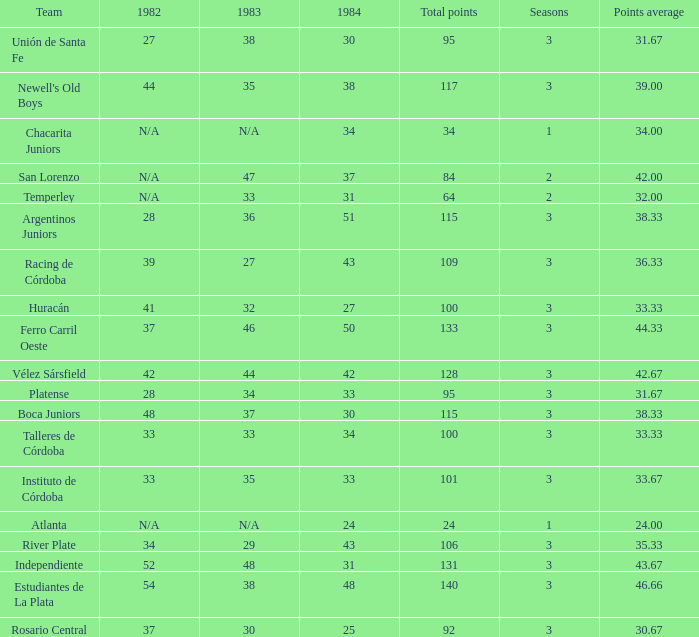Can you give me this table as a dict? {'header': ['Team', '1982', '1983', '1984', 'Total points', 'Seasons', 'Points average'], 'rows': [['Unión de Santa Fe', '27', '38', '30', '95', '3', '31.67'], ["Newell's Old Boys", '44', '35', '38', '117', '3', '39.00'], ['Chacarita Juniors', 'N/A', 'N/A', '34', '34', '1', '34.00'], ['San Lorenzo', 'N/A', '47', '37', '84', '2', '42.00'], ['Temperley', 'N/A', '33', '31', '64', '2', '32.00'], ['Argentinos Juniors', '28', '36', '51', '115', '3', '38.33'], ['Racing de Córdoba', '39', '27', '43', '109', '3', '36.33'], ['Huracán', '41', '32', '27', '100', '3', '33.33'], ['Ferro Carril Oeste', '37', '46', '50', '133', '3', '44.33'], ['Vélez Sársfield', '42', '44', '42', '128', '3', '42.67'], ['Platense', '28', '34', '33', '95', '3', '31.67'], ['Boca Juniors', '48', '37', '30', '115', '3', '38.33'], ['Talleres de Córdoba', '33', '33', '34', '100', '3', '33.33'], ['Instituto de Córdoba', '33', '35', '33', '101', '3', '33.67'], ['Atlanta', 'N/A', 'N/A', '24', '24', '1', '24.00'], ['River Plate', '34', '29', '43', '106', '3', '35.33'], ['Independiente', '52', '48', '31', '131', '3', '43.67'], ['Estudiantes de La Plata', '54', '38', '48', '140', '3', '46.66'], ['Rosario Central', '37', '30', '25', '92', '3', '30.67']]} What team had 3 seasons and fewer than 27 in 1984? Rosario Central. 